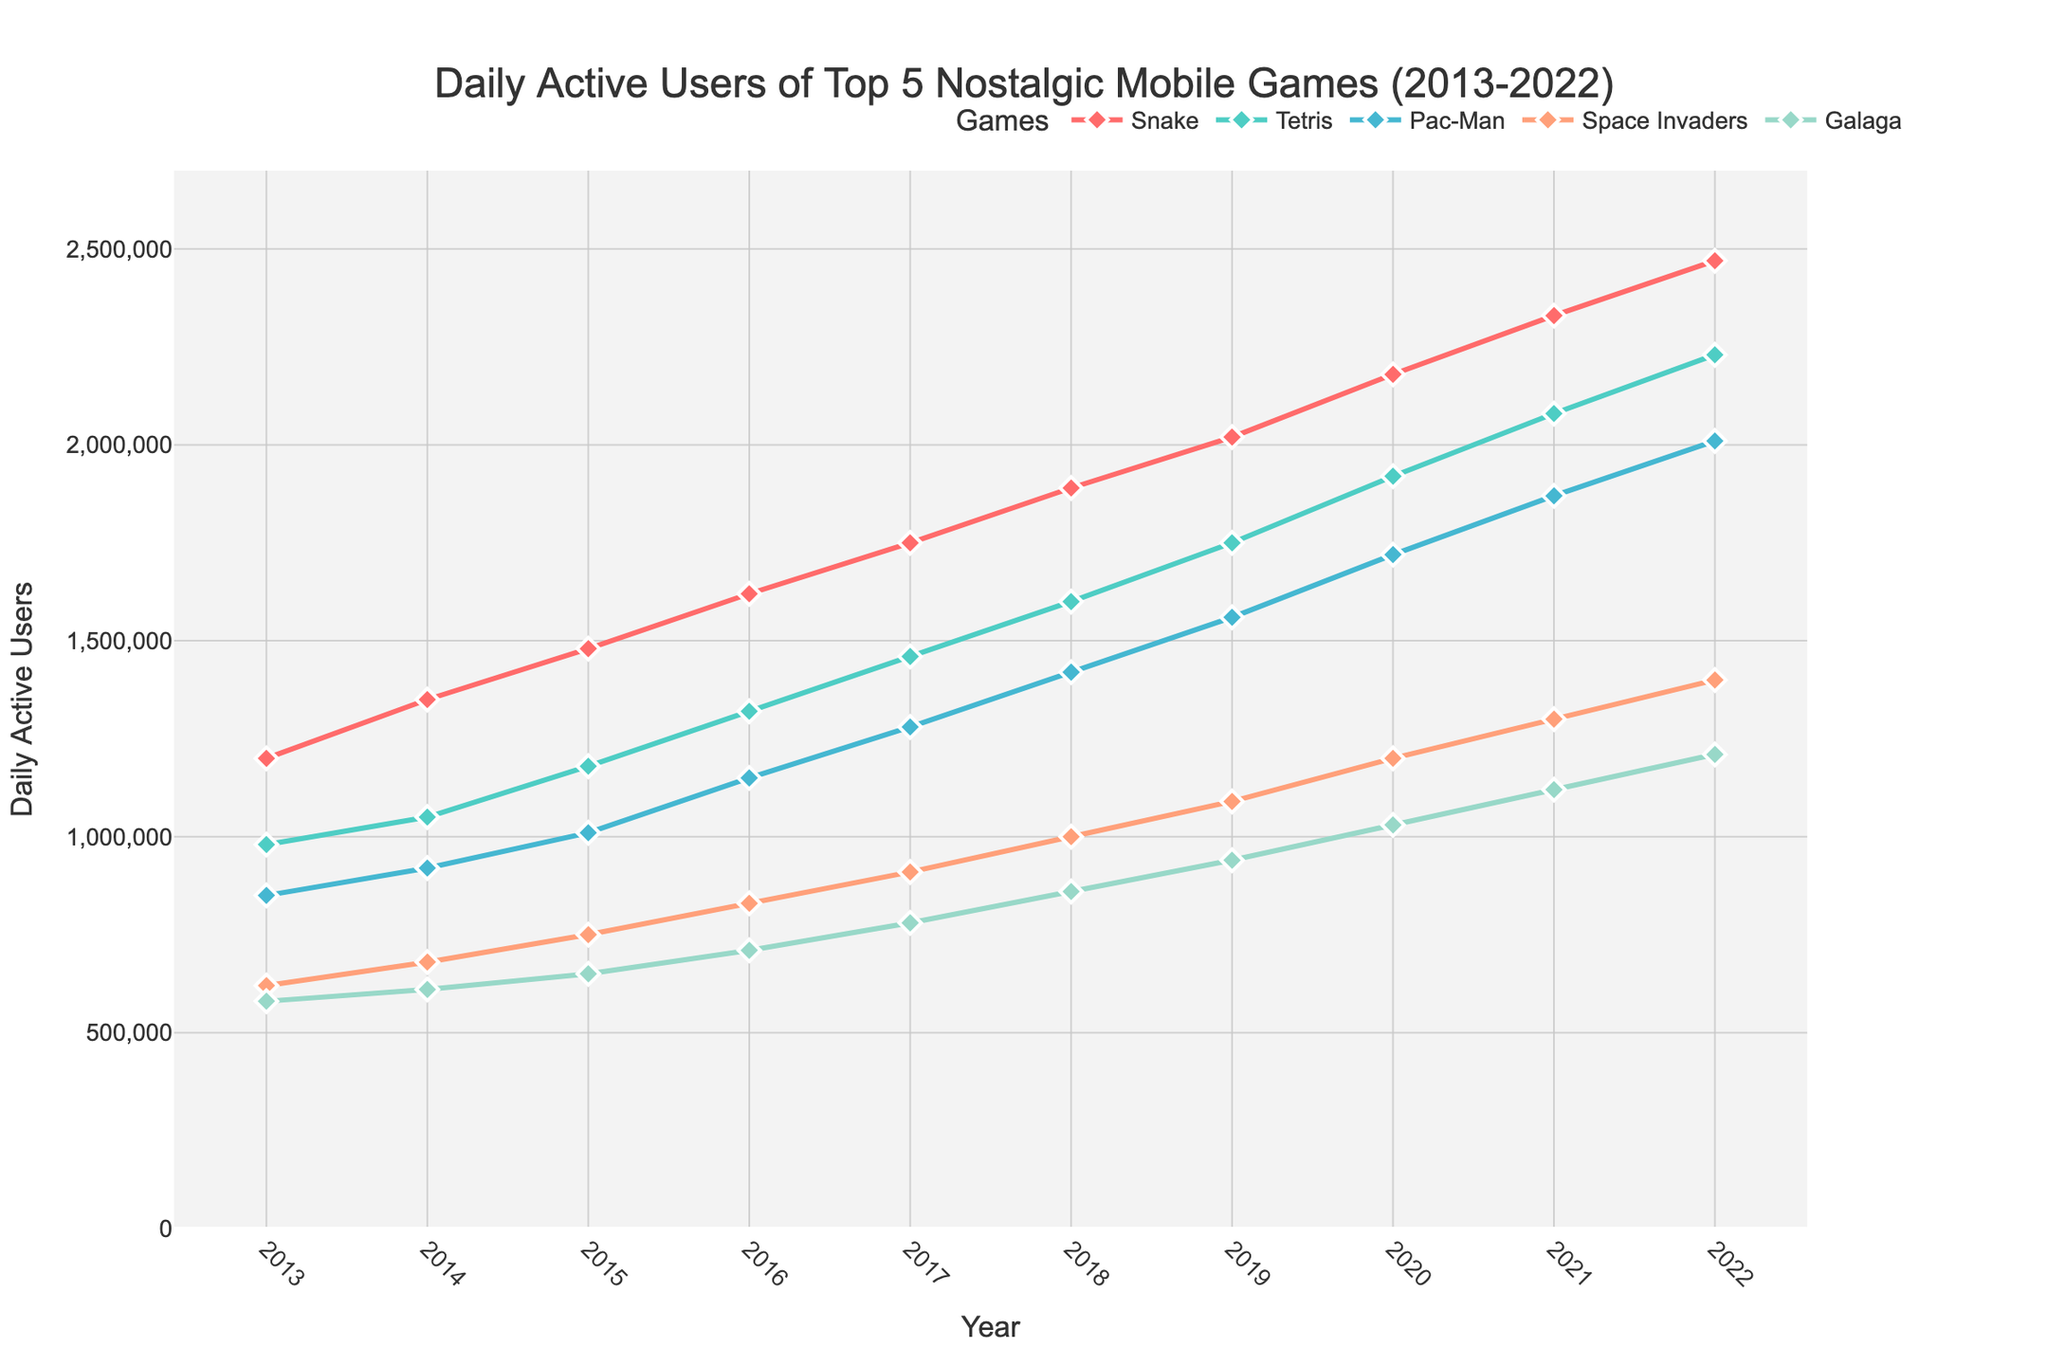Which game had the highest number of daily active users in 2022? Check the y-axis values for 2022 for all games and identify the highest one. Snake has 2,470,000 daily active users, which is the highest in 2022.
Answer: Snake Which two games showed the closest number of daily active users at the start and end of the dataset? For each year, calculate the difference in daily active users between all possible pairs of games for 2013 and 2022. Tetris and Pac-Man have the closest numbers in both 2013 (980,000 vs. 850,000) and 2022 (2,230,000 vs. 2,010,000).
Answer: Tetris and Pac-Man Which game experienced the greatest increase in daily active users over the period 2013-2022? Subtract the 2013 daily active users from the 2022 daily active users for each game and identify which game has the largest increase. Snake increased by 1,270,000 users, which is the greatest increase.
Answer: Snake In which year did Space Invaders have the smallest difference in daily active users compared to Galaga? Calculate the difference in daily active users between Space Invaders and Galaga for each year and find the year with the smallest difference. In 2022, the difference is 190,000 which is the smallest.
Answer: 2022 What was the average number of daily active users for Pac-Man over the 10-year period? Add the daily active users for Pac-Man from all years and divide by the number of years. The sum is 126,000,000 and the average is 1,260,000.
Answer: 1,260,000 Which year saw the highest overall daily active users when all games are combined? Sum the daily active users for all games for each year, then identify the year with the highest sum. 2022 has the highest overall users with a sum of 9,510,000.
Answer: 2022 Which game had the most consistent growth in daily active users from 2013 to 2022? Examine the graph to see which line steadily increased without any drops or plateaus. Tetris shows consistent growth over the entire period.
Answer: Tetris In which year did Galaga first surpass 1,000,000 daily active users? Check the y-axis values year by year for Galaga. It first surpassed 1,000,000 in 2020.
Answer: 2020 How does the growth rate of Pac-Man compare to Space Invaders from 2013 to 2017? Calculate the growth (difference in users) for each game from 2013 to 2017, then compare the growth rates. Pac-Man increased by 430,000 and Space Invaders by 290,000, so Pac-Man had a higher growth rate.
Answer: Pac-Man 